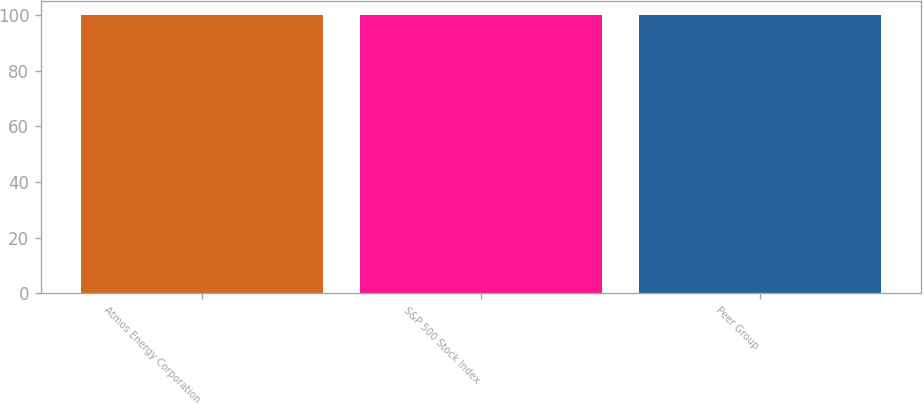Convert chart. <chart><loc_0><loc_0><loc_500><loc_500><bar_chart><fcel>Atmos Energy Corporation<fcel>S&P 500 Stock Index<fcel>Peer Group<nl><fcel>100<fcel>100.1<fcel>100.2<nl></chart> 